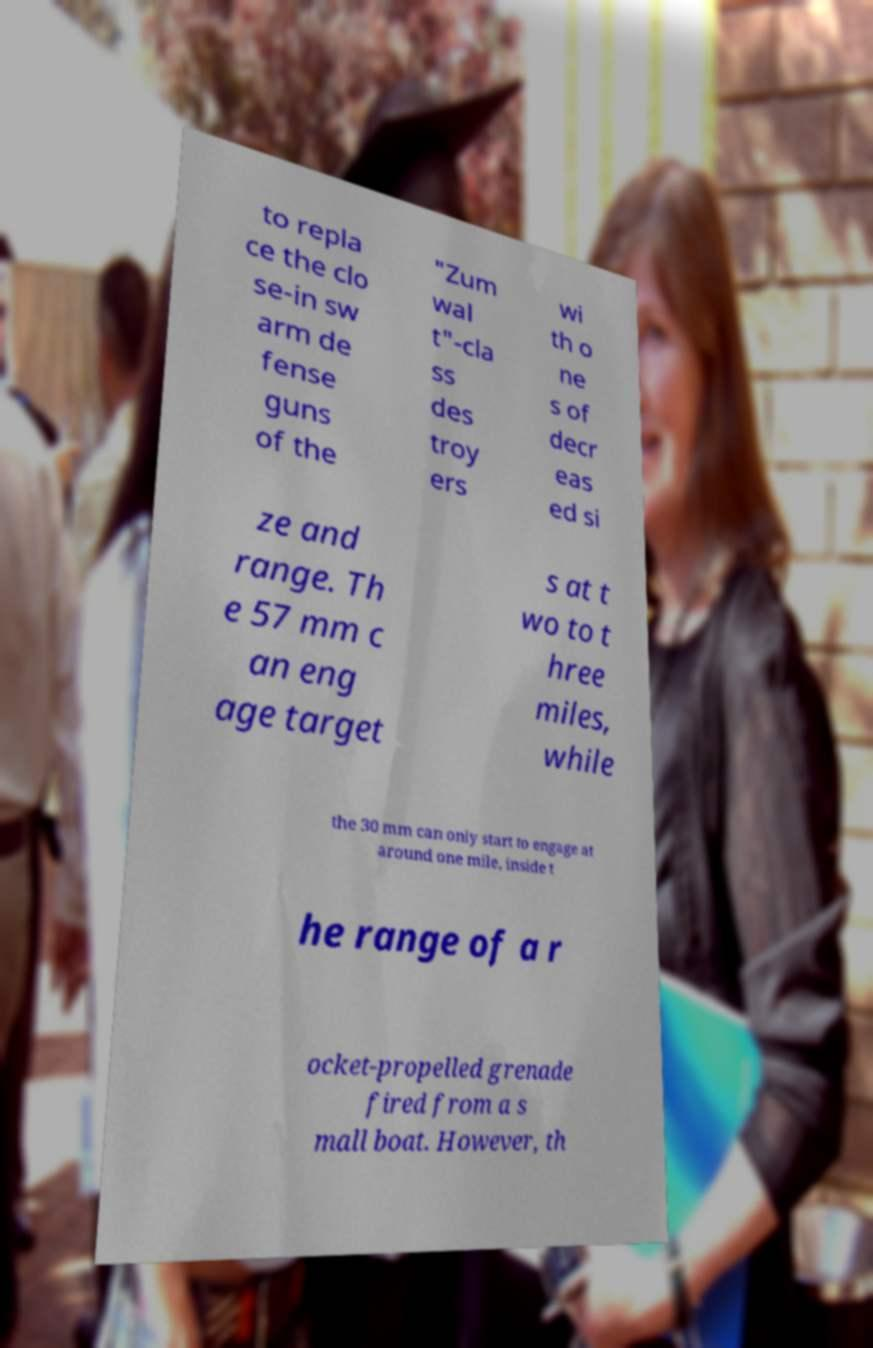Can you read and provide the text displayed in the image?This photo seems to have some interesting text. Can you extract and type it out for me? to repla ce the clo se-in sw arm de fense guns of the "Zum wal t"-cla ss des troy ers wi th o ne s of decr eas ed si ze and range. Th e 57 mm c an eng age target s at t wo to t hree miles, while the 30 mm can only start to engage at around one mile, inside t he range of a r ocket-propelled grenade fired from a s mall boat. However, th 